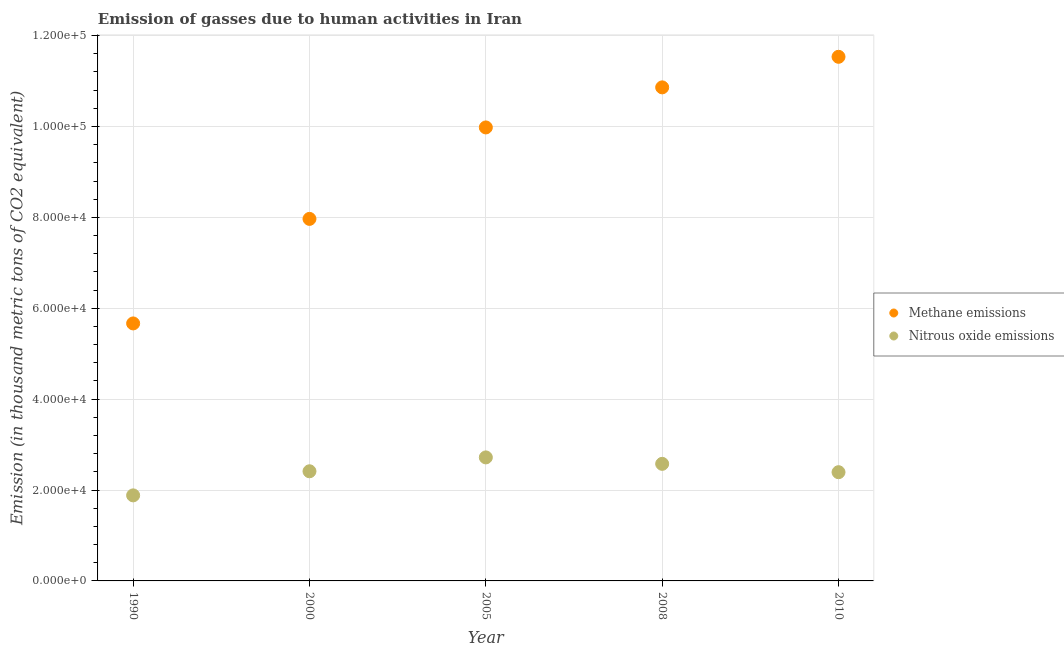What is the amount of methane emissions in 2010?
Provide a succinct answer. 1.15e+05. Across all years, what is the maximum amount of nitrous oxide emissions?
Provide a succinct answer. 2.72e+04. Across all years, what is the minimum amount of nitrous oxide emissions?
Keep it short and to the point. 1.88e+04. What is the total amount of nitrous oxide emissions in the graph?
Keep it short and to the point. 1.20e+05. What is the difference between the amount of methane emissions in 2005 and that in 2010?
Give a very brief answer. -1.55e+04. What is the difference between the amount of methane emissions in 1990 and the amount of nitrous oxide emissions in 2008?
Make the answer very short. 3.09e+04. What is the average amount of nitrous oxide emissions per year?
Your answer should be compact. 2.40e+04. In the year 2000, what is the difference between the amount of nitrous oxide emissions and amount of methane emissions?
Give a very brief answer. -5.55e+04. In how many years, is the amount of nitrous oxide emissions greater than 48000 thousand metric tons?
Provide a succinct answer. 0. What is the ratio of the amount of nitrous oxide emissions in 1990 to that in 2000?
Your response must be concise. 0.78. Is the amount of methane emissions in 2000 less than that in 2008?
Make the answer very short. Yes. What is the difference between the highest and the second highest amount of nitrous oxide emissions?
Provide a succinct answer. 1417.1. What is the difference between the highest and the lowest amount of methane emissions?
Your response must be concise. 5.87e+04. In how many years, is the amount of nitrous oxide emissions greater than the average amount of nitrous oxide emissions taken over all years?
Provide a succinct answer. 3. Is the amount of nitrous oxide emissions strictly greater than the amount of methane emissions over the years?
Your answer should be very brief. No. Is the amount of nitrous oxide emissions strictly less than the amount of methane emissions over the years?
Make the answer very short. Yes. How many dotlines are there?
Offer a very short reply. 2. How many years are there in the graph?
Give a very brief answer. 5. What is the difference between two consecutive major ticks on the Y-axis?
Make the answer very short. 2.00e+04. Does the graph contain any zero values?
Your answer should be compact. No. Does the graph contain grids?
Make the answer very short. Yes. Where does the legend appear in the graph?
Provide a succinct answer. Center right. How are the legend labels stacked?
Your answer should be compact. Vertical. What is the title of the graph?
Ensure brevity in your answer.  Emission of gasses due to human activities in Iran. Does "Lowest 20% of population" appear as one of the legend labels in the graph?
Give a very brief answer. No. What is the label or title of the X-axis?
Keep it short and to the point. Year. What is the label or title of the Y-axis?
Give a very brief answer. Emission (in thousand metric tons of CO2 equivalent). What is the Emission (in thousand metric tons of CO2 equivalent) in Methane emissions in 1990?
Ensure brevity in your answer.  5.67e+04. What is the Emission (in thousand metric tons of CO2 equivalent) in Nitrous oxide emissions in 1990?
Keep it short and to the point. 1.88e+04. What is the Emission (in thousand metric tons of CO2 equivalent) of Methane emissions in 2000?
Your answer should be very brief. 7.97e+04. What is the Emission (in thousand metric tons of CO2 equivalent) in Nitrous oxide emissions in 2000?
Your response must be concise. 2.41e+04. What is the Emission (in thousand metric tons of CO2 equivalent) of Methane emissions in 2005?
Ensure brevity in your answer.  9.98e+04. What is the Emission (in thousand metric tons of CO2 equivalent) in Nitrous oxide emissions in 2005?
Offer a very short reply. 2.72e+04. What is the Emission (in thousand metric tons of CO2 equivalent) of Methane emissions in 2008?
Make the answer very short. 1.09e+05. What is the Emission (in thousand metric tons of CO2 equivalent) of Nitrous oxide emissions in 2008?
Ensure brevity in your answer.  2.58e+04. What is the Emission (in thousand metric tons of CO2 equivalent) in Methane emissions in 2010?
Your answer should be compact. 1.15e+05. What is the Emission (in thousand metric tons of CO2 equivalent) in Nitrous oxide emissions in 2010?
Your answer should be very brief. 2.39e+04. Across all years, what is the maximum Emission (in thousand metric tons of CO2 equivalent) in Methane emissions?
Your response must be concise. 1.15e+05. Across all years, what is the maximum Emission (in thousand metric tons of CO2 equivalent) of Nitrous oxide emissions?
Your answer should be compact. 2.72e+04. Across all years, what is the minimum Emission (in thousand metric tons of CO2 equivalent) in Methane emissions?
Your response must be concise. 5.67e+04. Across all years, what is the minimum Emission (in thousand metric tons of CO2 equivalent) of Nitrous oxide emissions?
Give a very brief answer. 1.88e+04. What is the total Emission (in thousand metric tons of CO2 equivalent) in Methane emissions in the graph?
Your answer should be compact. 4.60e+05. What is the total Emission (in thousand metric tons of CO2 equivalent) of Nitrous oxide emissions in the graph?
Make the answer very short. 1.20e+05. What is the difference between the Emission (in thousand metric tons of CO2 equivalent) of Methane emissions in 1990 and that in 2000?
Provide a succinct answer. -2.30e+04. What is the difference between the Emission (in thousand metric tons of CO2 equivalent) of Nitrous oxide emissions in 1990 and that in 2000?
Your response must be concise. -5303. What is the difference between the Emission (in thousand metric tons of CO2 equivalent) in Methane emissions in 1990 and that in 2005?
Your answer should be very brief. -4.31e+04. What is the difference between the Emission (in thousand metric tons of CO2 equivalent) of Nitrous oxide emissions in 1990 and that in 2005?
Ensure brevity in your answer.  -8355.6. What is the difference between the Emission (in thousand metric tons of CO2 equivalent) in Methane emissions in 1990 and that in 2008?
Offer a very short reply. -5.19e+04. What is the difference between the Emission (in thousand metric tons of CO2 equivalent) in Nitrous oxide emissions in 1990 and that in 2008?
Your response must be concise. -6938.5. What is the difference between the Emission (in thousand metric tons of CO2 equivalent) in Methane emissions in 1990 and that in 2010?
Your response must be concise. -5.87e+04. What is the difference between the Emission (in thousand metric tons of CO2 equivalent) of Nitrous oxide emissions in 1990 and that in 2010?
Ensure brevity in your answer.  -5102.4. What is the difference between the Emission (in thousand metric tons of CO2 equivalent) in Methane emissions in 2000 and that in 2005?
Keep it short and to the point. -2.01e+04. What is the difference between the Emission (in thousand metric tons of CO2 equivalent) of Nitrous oxide emissions in 2000 and that in 2005?
Provide a short and direct response. -3052.6. What is the difference between the Emission (in thousand metric tons of CO2 equivalent) of Methane emissions in 2000 and that in 2008?
Ensure brevity in your answer.  -2.89e+04. What is the difference between the Emission (in thousand metric tons of CO2 equivalent) in Nitrous oxide emissions in 2000 and that in 2008?
Your answer should be compact. -1635.5. What is the difference between the Emission (in thousand metric tons of CO2 equivalent) of Methane emissions in 2000 and that in 2010?
Make the answer very short. -3.57e+04. What is the difference between the Emission (in thousand metric tons of CO2 equivalent) in Nitrous oxide emissions in 2000 and that in 2010?
Your response must be concise. 200.6. What is the difference between the Emission (in thousand metric tons of CO2 equivalent) in Methane emissions in 2005 and that in 2008?
Ensure brevity in your answer.  -8816.1. What is the difference between the Emission (in thousand metric tons of CO2 equivalent) in Nitrous oxide emissions in 2005 and that in 2008?
Offer a very short reply. 1417.1. What is the difference between the Emission (in thousand metric tons of CO2 equivalent) of Methane emissions in 2005 and that in 2010?
Offer a very short reply. -1.55e+04. What is the difference between the Emission (in thousand metric tons of CO2 equivalent) in Nitrous oxide emissions in 2005 and that in 2010?
Make the answer very short. 3253.2. What is the difference between the Emission (in thousand metric tons of CO2 equivalent) in Methane emissions in 2008 and that in 2010?
Offer a terse response. -6726.3. What is the difference between the Emission (in thousand metric tons of CO2 equivalent) of Nitrous oxide emissions in 2008 and that in 2010?
Ensure brevity in your answer.  1836.1. What is the difference between the Emission (in thousand metric tons of CO2 equivalent) in Methane emissions in 1990 and the Emission (in thousand metric tons of CO2 equivalent) in Nitrous oxide emissions in 2000?
Keep it short and to the point. 3.25e+04. What is the difference between the Emission (in thousand metric tons of CO2 equivalent) of Methane emissions in 1990 and the Emission (in thousand metric tons of CO2 equivalent) of Nitrous oxide emissions in 2005?
Keep it short and to the point. 2.95e+04. What is the difference between the Emission (in thousand metric tons of CO2 equivalent) of Methane emissions in 1990 and the Emission (in thousand metric tons of CO2 equivalent) of Nitrous oxide emissions in 2008?
Your response must be concise. 3.09e+04. What is the difference between the Emission (in thousand metric tons of CO2 equivalent) in Methane emissions in 1990 and the Emission (in thousand metric tons of CO2 equivalent) in Nitrous oxide emissions in 2010?
Your response must be concise. 3.27e+04. What is the difference between the Emission (in thousand metric tons of CO2 equivalent) in Methane emissions in 2000 and the Emission (in thousand metric tons of CO2 equivalent) in Nitrous oxide emissions in 2005?
Keep it short and to the point. 5.25e+04. What is the difference between the Emission (in thousand metric tons of CO2 equivalent) of Methane emissions in 2000 and the Emission (in thousand metric tons of CO2 equivalent) of Nitrous oxide emissions in 2008?
Your answer should be very brief. 5.39e+04. What is the difference between the Emission (in thousand metric tons of CO2 equivalent) of Methane emissions in 2000 and the Emission (in thousand metric tons of CO2 equivalent) of Nitrous oxide emissions in 2010?
Offer a very short reply. 5.57e+04. What is the difference between the Emission (in thousand metric tons of CO2 equivalent) of Methane emissions in 2005 and the Emission (in thousand metric tons of CO2 equivalent) of Nitrous oxide emissions in 2008?
Make the answer very short. 7.40e+04. What is the difference between the Emission (in thousand metric tons of CO2 equivalent) in Methane emissions in 2005 and the Emission (in thousand metric tons of CO2 equivalent) in Nitrous oxide emissions in 2010?
Give a very brief answer. 7.59e+04. What is the difference between the Emission (in thousand metric tons of CO2 equivalent) of Methane emissions in 2008 and the Emission (in thousand metric tons of CO2 equivalent) of Nitrous oxide emissions in 2010?
Keep it short and to the point. 8.47e+04. What is the average Emission (in thousand metric tons of CO2 equivalent) in Methane emissions per year?
Your answer should be very brief. 9.20e+04. What is the average Emission (in thousand metric tons of CO2 equivalent) of Nitrous oxide emissions per year?
Offer a very short reply. 2.40e+04. In the year 1990, what is the difference between the Emission (in thousand metric tons of CO2 equivalent) of Methane emissions and Emission (in thousand metric tons of CO2 equivalent) of Nitrous oxide emissions?
Provide a succinct answer. 3.78e+04. In the year 2000, what is the difference between the Emission (in thousand metric tons of CO2 equivalent) of Methane emissions and Emission (in thousand metric tons of CO2 equivalent) of Nitrous oxide emissions?
Make the answer very short. 5.55e+04. In the year 2005, what is the difference between the Emission (in thousand metric tons of CO2 equivalent) of Methane emissions and Emission (in thousand metric tons of CO2 equivalent) of Nitrous oxide emissions?
Ensure brevity in your answer.  7.26e+04. In the year 2008, what is the difference between the Emission (in thousand metric tons of CO2 equivalent) of Methane emissions and Emission (in thousand metric tons of CO2 equivalent) of Nitrous oxide emissions?
Your answer should be compact. 8.28e+04. In the year 2010, what is the difference between the Emission (in thousand metric tons of CO2 equivalent) of Methane emissions and Emission (in thousand metric tons of CO2 equivalent) of Nitrous oxide emissions?
Offer a very short reply. 9.14e+04. What is the ratio of the Emission (in thousand metric tons of CO2 equivalent) of Methane emissions in 1990 to that in 2000?
Keep it short and to the point. 0.71. What is the ratio of the Emission (in thousand metric tons of CO2 equivalent) in Nitrous oxide emissions in 1990 to that in 2000?
Your answer should be very brief. 0.78. What is the ratio of the Emission (in thousand metric tons of CO2 equivalent) in Methane emissions in 1990 to that in 2005?
Provide a short and direct response. 0.57. What is the ratio of the Emission (in thousand metric tons of CO2 equivalent) of Nitrous oxide emissions in 1990 to that in 2005?
Your answer should be compact. 0.69. What is the ratio of the Emission (in thousand metric tons of CO2 equivalent) in Methane emissions in 1990 to that in 2008?
Your answer should be compact. 0.52. What is the ratio of the Emission (in thousand metric tons of CO2 equivalent) of Nitrous oxide emissions in 1990 to that in 2008?
Keep it short and to the point. 0.73. What is the ratio of the Emission (in thousand metric tons of CO2 equivalent) of Methane emissions in 1990 to that in 2010?
Give a very brief answer. 0.49. What is the ratio of the Emission (in thousand metric tons of CO2 equivalent) in Nitrous oxide emissions in 1990 to that in 2010?
Offer a very short reply. 0.79. What is the ratio of the Emission (in thousand metric tons of CO2 equivalent) of Methane emissions in 2000 to that in 2005?
Make the answer very short. 0.8. What is the ratio of the Emission (in thousand metric tons of CO2 equivalent) in Nitrous oxide emissions in 2000 to that in 2005?
Your answer should be very brief. 0.89. What is the ratio of the Emission (in thousand metric tons of CO2 equivalent) in Methane emissions in 2000 to that in 2008?
Provide a succinct answer. 0.73. What is the ratio of the Emission (in thousand metric tons of CO2 equivalent) in Nitrous oxide emissions in 2000 to that in 2008?
Your response must be concise. 0.94. What is the ratio of the Emission (in thousand metric tons of CO2 equivalent) in Methane emissions in 2000 to that in 2010?
Your answer should be very brief. 0.69. What is the ratio of the Emission (in thousand metric tons of CO2 equivalent) in Nitrous oxide emissions in 2000 to that in 2010?
Offer a very short reply. 1.01. What is the ratio of the Emission (in thousand metric tons of CO2 equivalent) in Methane emissions in 2005 to that in 2008?
Offer a terse response. 0.92. What is the ratio of the Emission (in thousand metric tons of CO2 equivalent) of Nitrous oxide emissions in 2005 to that in 2008?
Provide a short and direct response. 1.05. What is the ratio of the Emission (in thousand metric tons of CO2 equivalent) of Methane emissions in 2005 to that in 2010?
Offer a terse response. 0.87. What is the ratio of the Emission (in thousand metric tons of CO2 equivalent) in Nitrous oxide emissions in 2005 to that in 2010?
Keep it short and to the point. 1.14. What is the ratio of the Emission (in thousand metric tons of CO2 equivalent) in Methane emissions in 2008 to that in 2010?
Offer a terse response. 0.94. What is the ratio of the Emission (in thousand metric tons of CO2 equivalent) in Nitrous oxide emissions in 2008 to that in 2010?
Your answer should be compact. 1.08. What is the difference between the highest and the second highest Emission (in thousand metric tons of CO2 equivalent) in Methane emissions?
Give a very brief answer. 6726.3. What is the difference between the highest and the second highest Emission (in thousand metric tons of CO2 equivalent) of Nitrous oxide emissions?
Your response must be concise. 1417.1. What is the difference between the highest and the lowest Emission (in thousand metric tons of CO2 equivalent) of Methane emissions?
Your answer should be very brief. 5.87e+04. What is the difference between the highest and the lowest Emission (in thousand metric tons of CO2 equivalent) of Nitrous oxide emissions?
Your answer should be compact. 8355.6. 